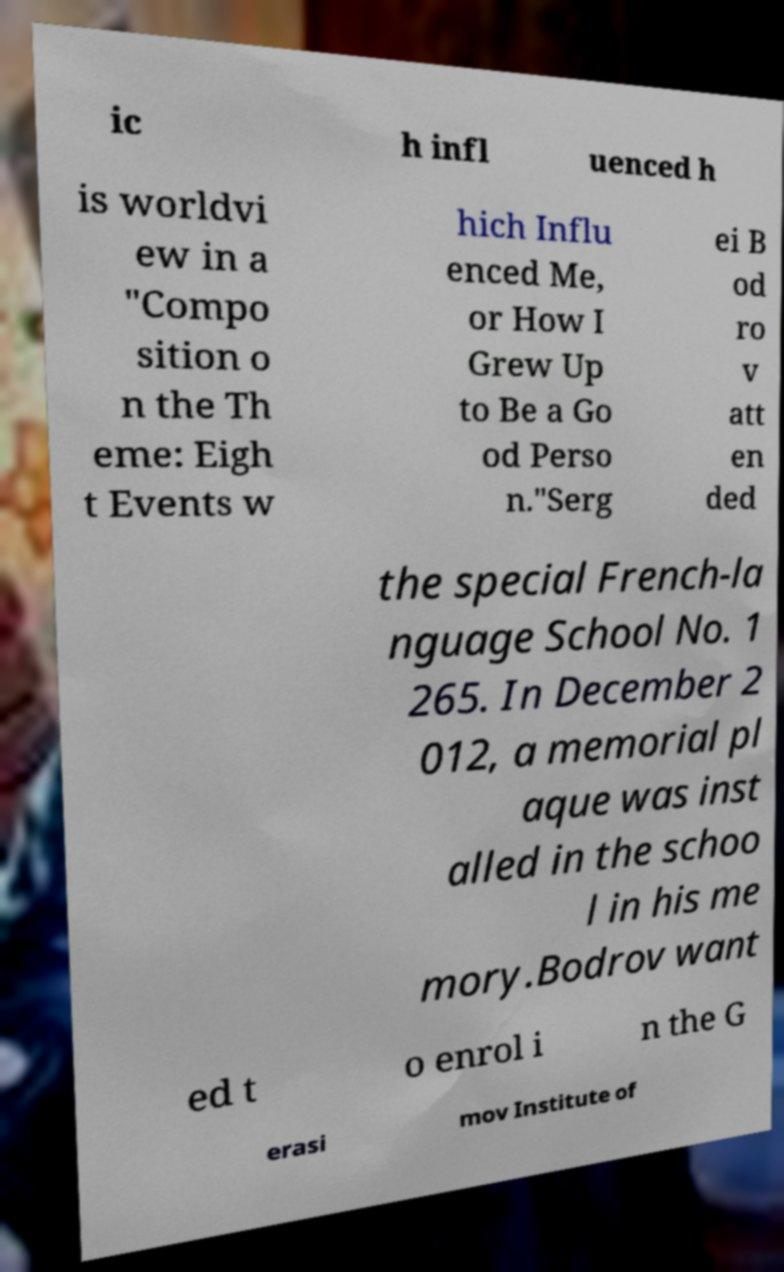Please read and relay the text visible in this image. What does it say? ic h infl uenced h is worldvi ew in a "Compo sition o n the Th eme: Eigh t Events w hich Influ enced Me, or How I Grew Up to Be a Go od Perso n."Serg ei B od ro v att en ded the special French-la nguage School No. 1 265. In December 2 012, a memorial pl aque was inst alled in the schoo l in his me mory.Bodrov want ed t o enrol i n the G erasi mov Institute of 